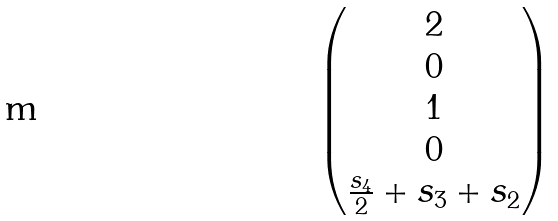<formula> <loc_0><loc_0><loc_500><loc_500>\begin{pmatrix} 2 \\ 0 \\ 1 \\ 0 \\ \frac { s _ { 4 } } { 2 } + s _ { 3 } + s _ { 2 } \end{pmatrix}</formula> 